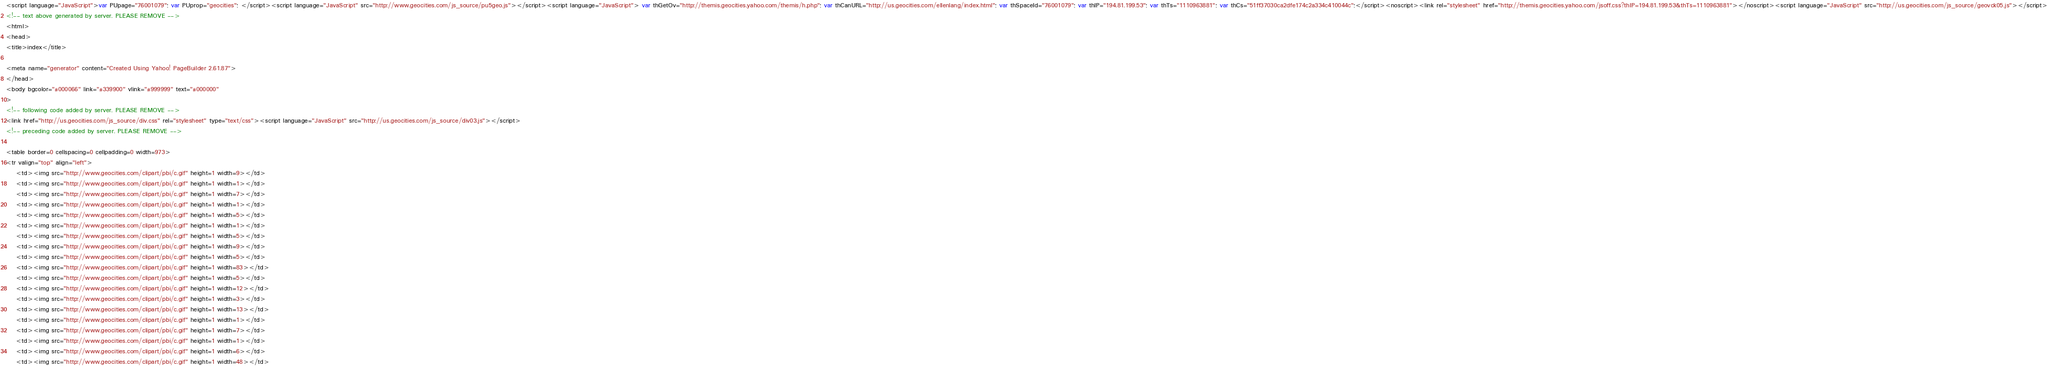Convert code to text. <code><loc_0><loc_0><loc_500><loc_500><_HTML_><script language="JavaScript">var PUpage="76001079"; var PUprop="geocities"; </script><script language="JavaScript" src="http://www.geocities.com/js_source/pu5geo.js"></script><script language="JavaScript"> var thGetOv="http://themis.geocities.yahoo.com/themis/h.php"; var thCanURL="http://us.geocities.com/ellenlang/index.html"; var thSpaceId="76001079"; var thIP="194.81.199.53"; var thTs="1110963881"; var thCs="51ff37030ca2dfe174c2a334c410044c";</script><noscript><link rel="stylesheet" href="http://themis.geocities.yahoo.com/jsoff.css?thIP=194.81.199.53&thTs=1110963881"></noscript><script language="JavaScript" src="http://us.geocities.com/js_source/geovck05.js"></script>
<!-- text above generated by server. PLEASE REMOVE -->
<html>
<head>
<title>index</title>

<meta name="generator" content="Created Using Yahoo! PageBuilder 2.61.87">
</head>
<body bgcolor="#000066" link="#339900" vlink="#999999" text="#000000"
>
<!-- following code added by server. PLEASE REMOVE -->
<link href="http://us.geocities.com/js_source/div.css" rel="stylesheet" type="text/css"><script language="JavaScript" src="http://us.geocities.com/js_source/div03.js"></script>
<!-- preceding code added by server. PLEASE REMOVE -->

<table border=0 cellspacing=0 cellpadding=0 width=973>
<tr valign="top" align="left">
	<td><img src="http://www.geocities.com/clipart/pbi/c.gif" height=1 width=9></td>
	<td><img src="http://www.geocities.com/clipart/pbi/c.gif" height=1 width=1></td>
	<td><img src="http://www.geocities.com/clipart/pbi/c.gif" height=1 width=7></td>
	<td><img src="http://www.geocities.com/clipart/pbi/c.gif" height=1 width=1></td>
	<td><img src="http://www.geocities.com/clipart/pbi/c.gif" height=1 width=5></td>
	<td><img src="http://www.geocities.com/clipart/pbi/c.gif" height=1 width=1></td>
	<td><img src="http://www.geocities.com/clipart/pbi/c.gif" height=1 width=5></td>
	<td><img src="http://www.geocities.com/clipart/pbi/c.gif" height=1 width=9></td>
	<td><img src="http://www.geocities.com/clipart/pbi/c.gif" height=1 width=5></td>
	<td><img src="http://www.geocities.com/clipart/pbi/c.gif" height=1 width=83></td>
	<td><img src="http://www.geocities.com/clipart/pbi/c.gif" height=1 width=5></td>
	<td><img src="http://www.geocities.com/clipart/pbi/c.gif" height=1 width=12></td>
	<td><img src="http://www.geocities.com/clipart/pbi/c.gif" height=1 width=3></td>
	<td><img src="http://www.geocities.com/clipart/pbi/c.gif" height=1 width=13></td>
	<td><img src="http://www.geocities.com/clipart/pbi/c.gif" height=1 width=1></td>
	<td><img src="http://www.geocities.com/clipart/pbi/c.gif" height=1 width=7></td>
	<td><img src="http://www.geocities.com/clipart/pbi/c.gif" height=1 width=1></td>
	<td><img src="http://www.geocities.com/clipart/pbi/c.gif" height=1 width=6></td>
	<td><img src="http://www.geocities.com/clipart/pbi/c.gif" height=1 width=48></td></code> 